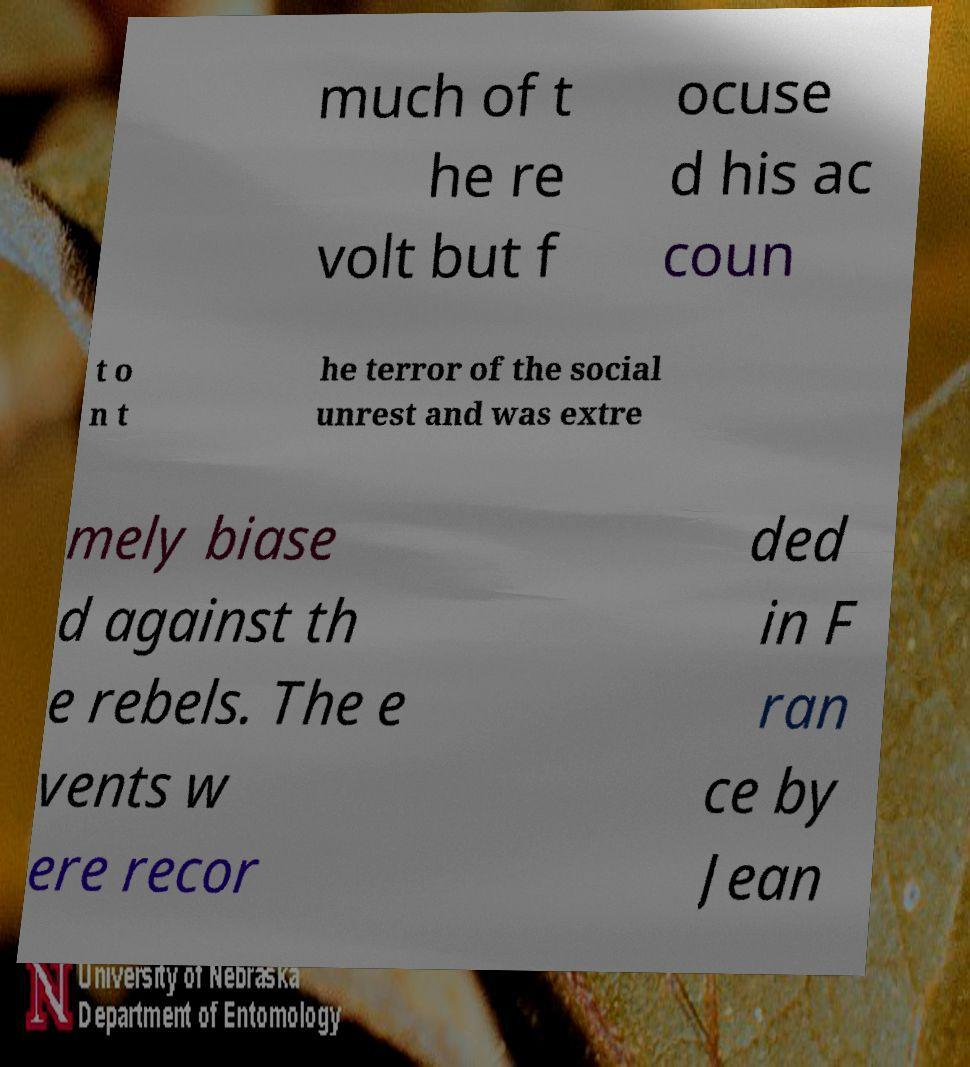I need the written content from this picture converted into text. Can you do that? much of t he re volt but f ocuse d his ac coun t o n t he terror of the social unrest and was extre mely biase d against th e rebels. The e vents w ere recor ded in F ran ce by Jean 